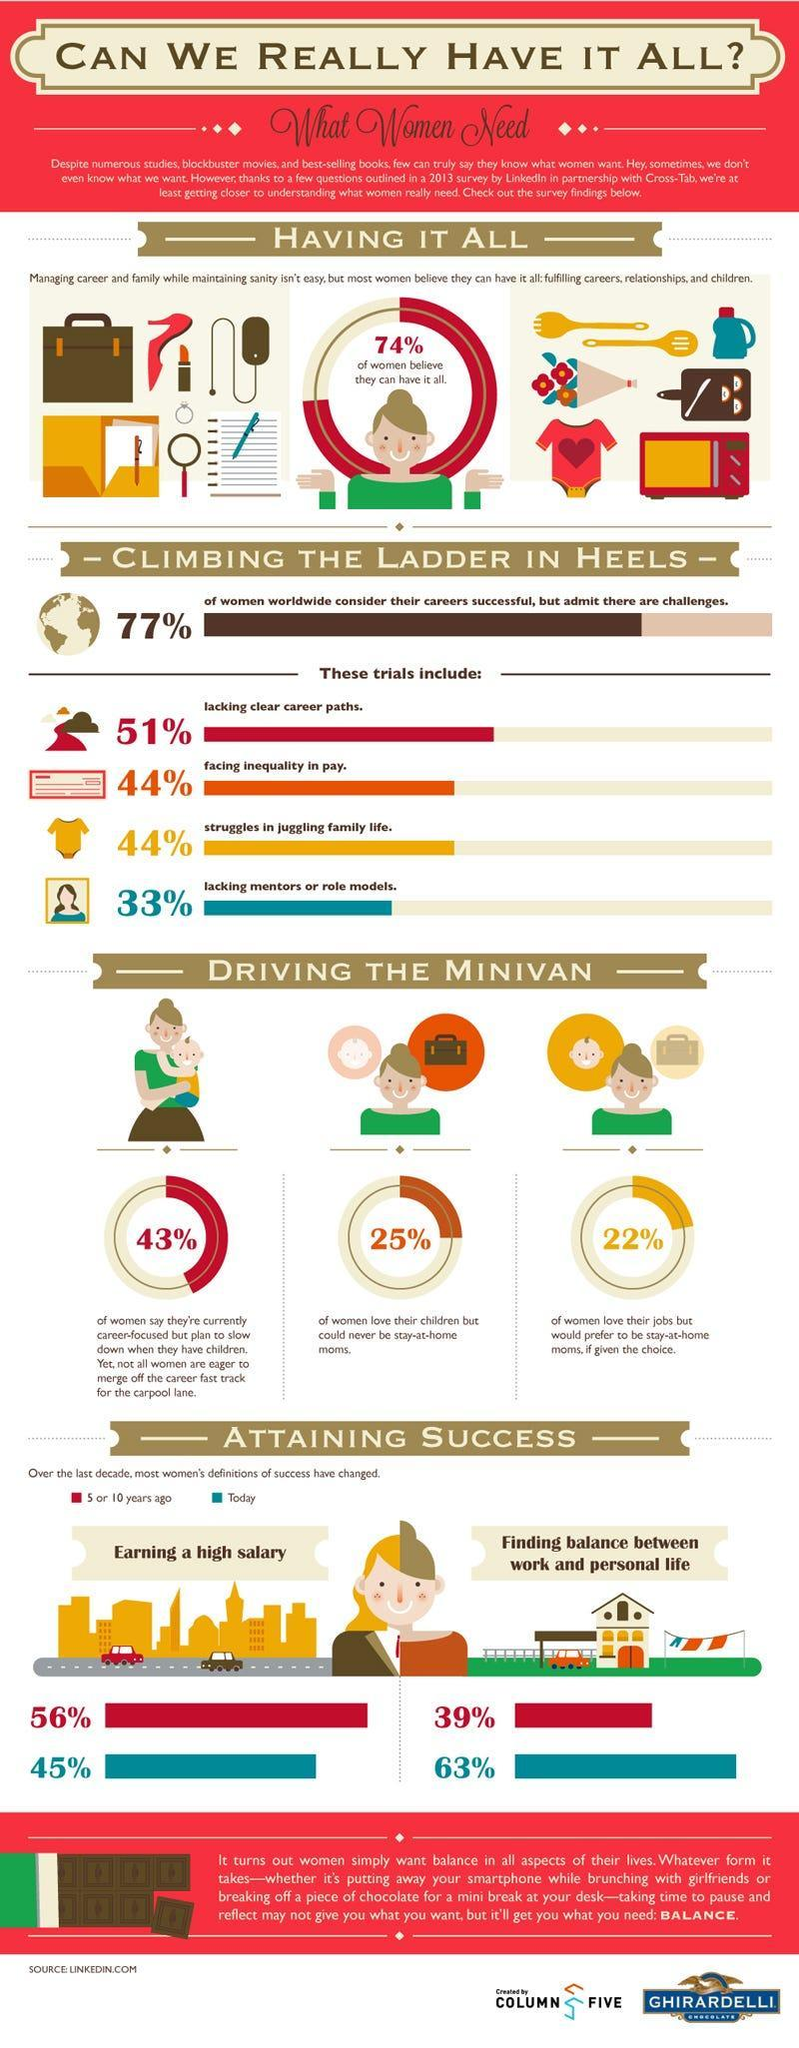How many of the women are career oriented but plan to slow down when they have kids?
Answer the question with a short phrase. 43% What percent of women today think that success means finding the perfect work-life balance? 63% 5 to 10 years ago what % of women though that success means finding the perfect work-personal life balance? 39% What percent of women love their children but do not want to be stay-at-home-moms? 25% What percent of women today think that definition of success means earning a high salary? 45% What percent of women think that they can manage both career and family? 74% 5 to 10 years ago what % of women though that success means earning a high salary? 56% What percent of women love their jobs, but if given the choice would like to be stay-at-home moms? 22% 